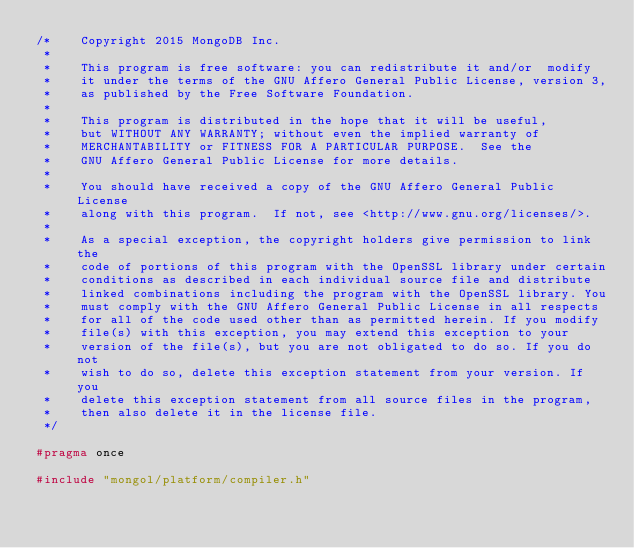Convert code to text. <code><loc_0><loc_0><loc_500><loc_500><_C_>/*    Copyright 2015 MongoDB Inc.
 *
 *    This program is free software: you can redistribute it and/or  modify
 *    it under the terms of the GNU Affero General Public License, version 3,
 *    as published by the Free Software Foundation.
 *
 *    This program is distributed in the hope that it will be useful,
 *    but WITHOUT ANY WARRANTY; without even the implied warranty of
 *    MERCHANTABILITY or FITNESS FOR A PARTICULAR PURPOSE.  See the
 *    GNU Affero General Public License for more details.
 *
 *    You should have received a copy of the GNU Affero General Public License
 *    along with this program.  If not, see <http://www.gnu.org/licenses/>.
 *
 *    As a special exception, the copyright holders give permission to link the
 *    code of portions of this program with the OpenSSL library under certain
 *    conditions as described in each individual source file and distribute
 *    linked combinations including the program with the OpenSSL library. You
 *    must comply with the GNU Affero General Public License in all respects
 *    for all of the code used other than as permitted herein. If you modify
 *    file(s) with this exception, you may extend this exception to your
 *    version of the file(s), but you are not obligated to do so. If you do not
 *    wish to do so, delete this exception statement from your version. If you
 *    delete this exception statement from all source files in the program,
 *    then also delete it in the license file.
 */

#pragma once

#include "mongol/platform/compiler.h"</code> 